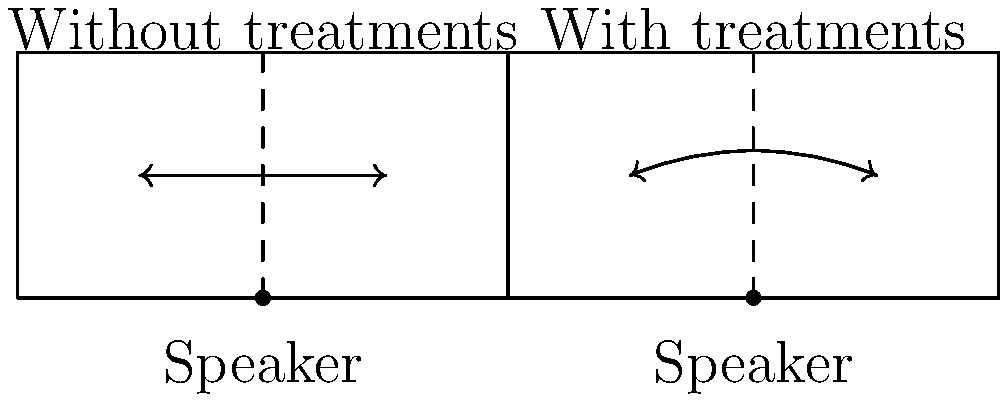Based on the illustration, which setup is more likely to reduce standing waves and improve overall sound quality in a home theater? To answer this question, let's analyze the two setups shown in the illustration:

1. Left side (Without treatments):
   - Sound waves are shown as straight lines bouncing back and forth.
   - This represents direct reflections off walls.
   - Such reflections can create standing waves, which cause frequency response irregularities.

2. Right side (With treatments):
   - Sound waves are shown as curved lines.
   - This represents diffusion and absorption of sound waves.
   - The curved path indicates that the sound energy is being scattered and absorbed.

3. Effects of acoustic treatments:
   - Reduce direct reflections
   - Minimize standing waves
   - Improve sound diffusion
   - Enhance overall sound quality

4. Standing waves:
   - Created by interference between incident and reflected waves
   - Can cause peaks and nulls in frequency response
   - More prominent in untreated rooms

5. Benefits of reducing standing waves:
   - More even frequency response
   - Improved clarity and definition in sound
   - Better stereo imaging and soundstage

Therefore, the setup with acoustic treatments (right side) is more likely to reduce standing waves and improve overall sound quality in a home theater.
Answer: The setup with acoustic treatments 